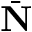Convert formula to latex. <formula><loc_0><loc_0><loc_500><loc_500>\bar { N }</formula> 